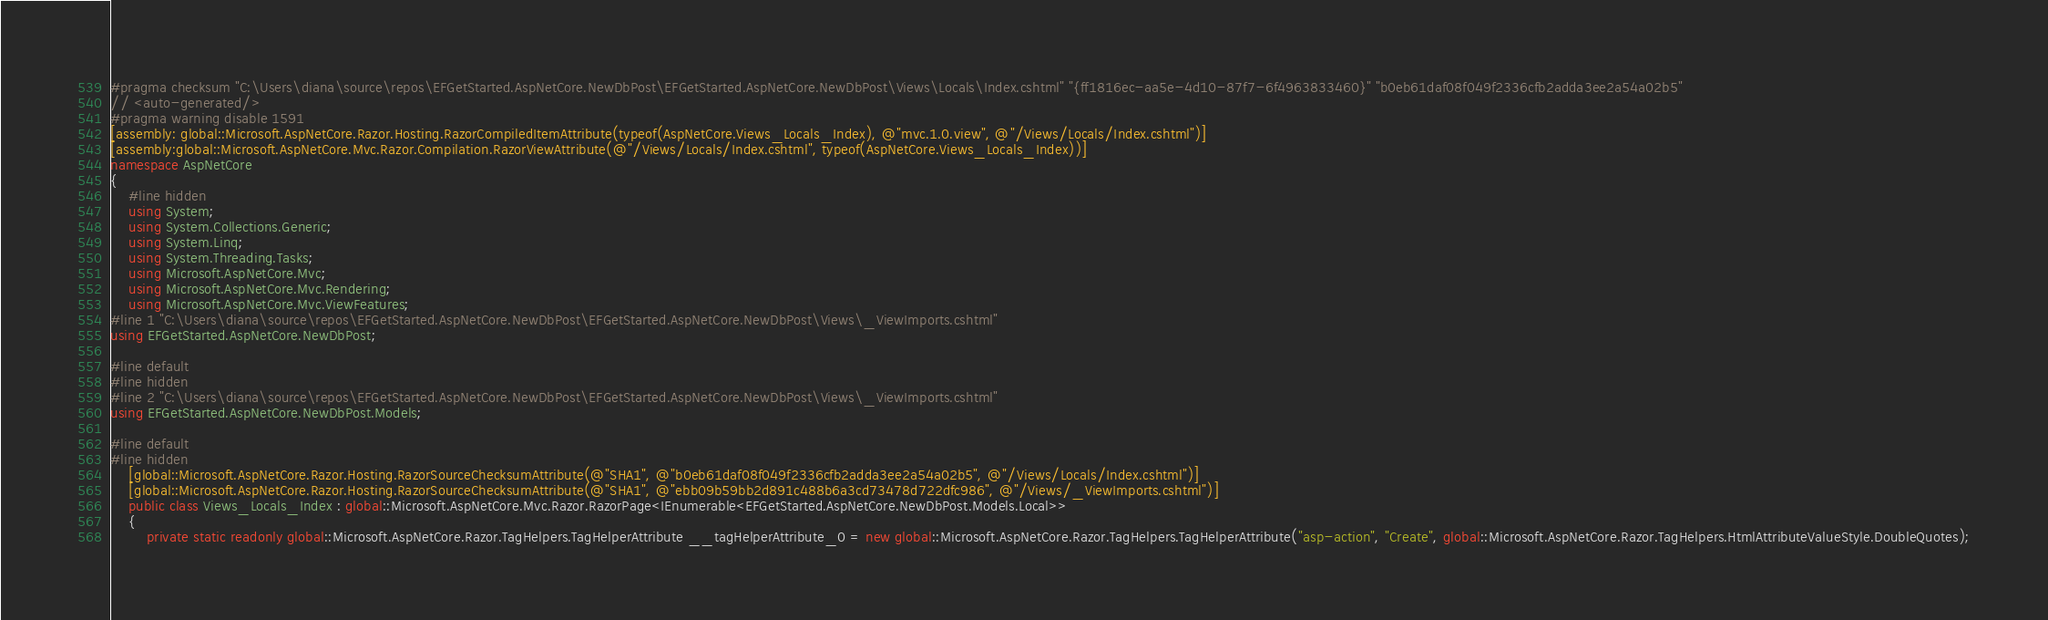<code> <loc_0><loc_0><loc_500><loc_500><_C#_>#pragma checksum "C:\Users\diana\source\repos\EFGetStarted.AspNetCore.NewDbPost\EFGetStarted.AspNetCore.NewDbPost\Views\Locals\Index.cshtml" "{ff1816ec-aa5e-4d10-87f7-6f4963833460}" "b0eb61daf08f049f2336cfb2adda3ee2a54a02b5"
// <auto-generated/>
#pragma warning disable 1591
[assembly: global::Microsoft.AspNetCore.Razor.Hosting.RazorCompiledItemAttribute(typeof(AspNetCore.Views_Locals_Index), @"mvc.1.0.view", @"/Views/Locals/Index.cshtml")]
[assembly:global::Microsoft.AspNetCore.Mvc.Razor.Compilation.RazorViewAttribute(@"/Views/Locals/Index.cshtml", typeof(AspNetCore.Views_Locals_Index))]
namespace AspNetCore
{
    #line hidden
    using System;
    using System.Collections.Generic;
    using System.Linq;
    using System.Threading.Tasks;
    using Microsoft.AspNetCore.Mvc;
    using Microsoft.AspNetCore.Mvc.Rendering;
    using Microsoft.AspNetCore.Mvc.ViewFeatures;
#line 1 "C:\Users\diana\source\repos\EFGetStarted.AspNetCore.NewDbPost\EFGetStarted.AspNetCore.NewDbPost\Views\_ViewImports.cshtml"
using EFGetStarted.AspNetCore.NewDbPost;

#line default
#line hidden
#line 2 "C:\Users\diana\source\repos\EFGetStarted.AspNetCore.NewDbPost\EFGetStarted.AspNetCore.NewDbPost\Views\_ViewImports.cshtml"
using EFGetStarted.AspNetCore.NewDbPost.Models;

#line default
#line hidden
    [global::Microsoft.AspNetCore.Razor.Hosting.RazorSourceChecksumAttribute(@"SHA1", @"b0eb61daf08f049f2336cfb2adda3ee2a54a02b5", @"/Views/Locals/Index.cshtml")]
    [global::Microsoft.AspNetCore.Razor.Hosting.RazorSourceChecksumAttribute(@"SHA1", @"ebb09b59bb2d891c488b6a3cd73478d722dfc986", @"/Views/_ViewImports.cshtml")]
    public class Views_Locals_Index : global::Microsoft.AspNetCore.Mvc.Razor.RazorPage<IEnumerable<EFGetStarted.AspNetCore.NewDbPost.Models.Local>>
    {
        private static readonly global::Microsoft.AspNetCore.Razor.TagHelpers.TagHelperAttribute __tagHelperAttribute_0 = new global::Microsoft.AspNetCore.Razor.TagHelpers.TagHelperAttribute("asp-action", "Create", global::Microsoft.AspNetCore.Razor.TagHelpers.HtmlAttributeValueStyle.DoubleQuotes);</code> 